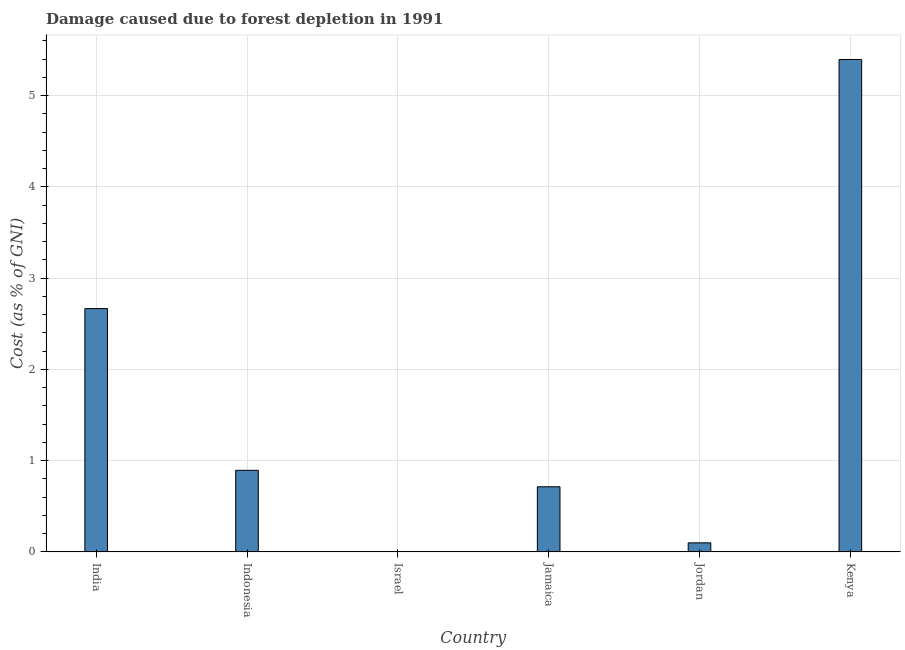Does the graph contain grids?
Make the answer very short. Yes. What is the title of the graph?
Provide a succinct answer. Damage caused due to forest depletion in 1991. What is the label or title of the Y-axis?
Keep it short and to the point. Cost (as % of GNI). What is the damage caused due to forest depletion in Israel?
Offer a very short reply. 0. Across all countries, what is the maximum damage caused due to forest depletion?
Provide a succinct answer. 5.4. Across all countries, what is the minimum damage caused due to forest depletion?
Offer a very short reply. 0. In which country was the damage caused due to forest depletion maximum?
Offer a very short reply. Kenya. In which country was the damage caused due to forest depletion minimum?
Your answer should be very brief. Israel. What is the sum of the damage caused due to forest depletion?
Your response must be concise. 9.77. What is the difference between the damage caused due to forest depletion in Indonesia and Jordan?
Give a very brief answer. 0.8. What is the average damage caused due to forest depletion per country?
Offer a very short reply. 1.63. What is the median damage caused due to forest depletion?
Provide a short and direct response. 0.8. In how many countries, is the damage caused due to forest depletion greater than 3.2 %?
Provide a short and direct response. 1. What is the ratio of the damage caused due to forest depletion in Indonesia to that in Jordan?
Ensure brevity in your answer.  9.03. Is the damage caused due to forest depletion in Israel less than that in Jordan?
Keep it short and to the point. Yes. What is the difference between the highest and the second highest damage caused due to forest depletion?
Your answer should be compact. 2.73. Is the sum of the damage caused due to forest depletion in India and Jamaica greater than the maximum damage caused due to forest depletion across all countries?
Ensure brevity in your answer.  No. What is the difference between the highest and the lowest damage caused due to forest depletion?
Your response must be concise. 5.39. In how many countries, is the damage caused due to forest depletion greater than the average damage caused due to forest depletion taken over all countries?
Your response must be concise. 2. Are all the bars in the graph horizontal?
Provide a succinct answer. No. How many countries are there in the graph?
Provide a short and direct response. 6. What is the difference between two consecutive major ticks on the Y-axis?
Make the answer very short. 1. What is the Cost (as % of GNI) in India?
Offer a very short reply. 2.67. What is the Cost (as % of GNI) in Indonesia?
Give a very brief answer. 0.89. What is the Cost (as % of GNI) in Israel?
Offer a very short reply. 0. What is the Cost (as % of GNI) in Jamaica?
Keep it short and to the point. 0.71. What is the Cost (as % of GNI) of Jordan?
Your answer should be compact. 0.1. What is the Cost (as % of GNI) of Kenya?
Offer a very short reply. 5.4. What is the difference between the Cost (as % of GNI) in India and Indonesia?
Keep it short and to the point. 1.77. What is the difference between the Cost (as % of GNI) in India and Israel?
Offer a very short reply. 2.66. What is the difference between the Cost (as % of GNI) in India and Jamaica?
Provide a succinct answer. 1.95. What is the difference between the Cost (as % of GNI) in India and Jordan?
Ensure brevity in your answer.  2.57. What is the difference between the Cost (as % of GNI) in India and Kenya?
Keep it short and to the point. -2.73. What is the difference between the Cost (as % of GNI) in Indonesia and Israel?
Offer a very short reply. 0.89. What is the difference between the Cost (as % of GNI) in Indonesia and Jamaica?
Give a very brief answer. 0.18. What is the difference between the Cost (as % of GNI) in Indonesia and Jordan?
Offer a very short reply. 0.79. What is the difference between the Cost (as % of GNI) in Indonesia and Kenya?
Ensure brevity in your answer.  -4.5. What is the difference between the Cost (as % of GNI) in Israel and Jamaica?
Provide a short and direct response. -0.71. What is the difference between the Cost (as % of GNI) in Israel and Jordan?
Keep it short and to the point. -0.1. What is the difference between the Cost (as % of GNI) in Israel and Kenya?
Give a very brief answer. -5.39. What is the difference between the Cost (as % of GNI) in Jamaica and Jordan?
Your response must be concise. 0.61. What is the difference between the Cost (as % of GNI) in Jamaica and Kenya?
Your response must be concise. -4.68. What is the difference between the Cost (as % of GNI) in Jordan and Kenya?
Offer a very short reply. -5.3. What is the ratio of the Cost (as % of GNI) in India to that in Indonesia?
Give a very brief answer. 2.98. What is the ratio of the Cost (as % of GNI) in India to that in Israel?
Ensure brevity in your answer.  1252.01. What is the ratio of the Cost (as % of GNI) in India to that in Jamaica?
Keep it short and to the point. 3.74. What is the ratio of the Cost (as % of GNI) in India to that in Jordan?
Your response must be concise. 26.94. What is the ratio of the Cost (as % of GNI) in India to that in Kenya?
Provide a succinct answer. 0.49. What is the ratio of the Cost (as % of GNI) in Indonesia to that in Israel?
Keep it short and to the point. 419.68. What is the ratio of the Cost (as % of GNI) in Indonesia to that in Jamaica?
Your answer should be very brief. 1.25. What is the ratio of the Cost (as % of GNI) in Indonesia to that in Jordan?
Your answer should be very brief. 9.03. What is the ratio of the Cost (as % of GNI) in Indonesia to that in Kenya?
Provide a short and direct response. 0.17. What is the ratio of the Cost (as % of GNI) in Israel to that in Jamaica?
Your answer should be very brief. 0. What is the ratio of the Cost (as % of GNI) in Israel to that in Jordan?
Ensure brevity in your answer.  0.02. What is the ratio of the Cost (as % of GNI) in Israel to that in Kenya?
Your answer should be very brief. 0. What is the ratio of the Cost (as % of GNI) in Jamaica to that in Jordan?
Keep it short and to the point. 7.21. What is the ratio of the Cost (as % of GNI) in Jamaica to that in Kenya?
Give a very brief answer. 0.13. What is the ratio of the Cost (as % of GNI) in Jordan to that in Kenya?
Your answer should be compact. 0.02. 